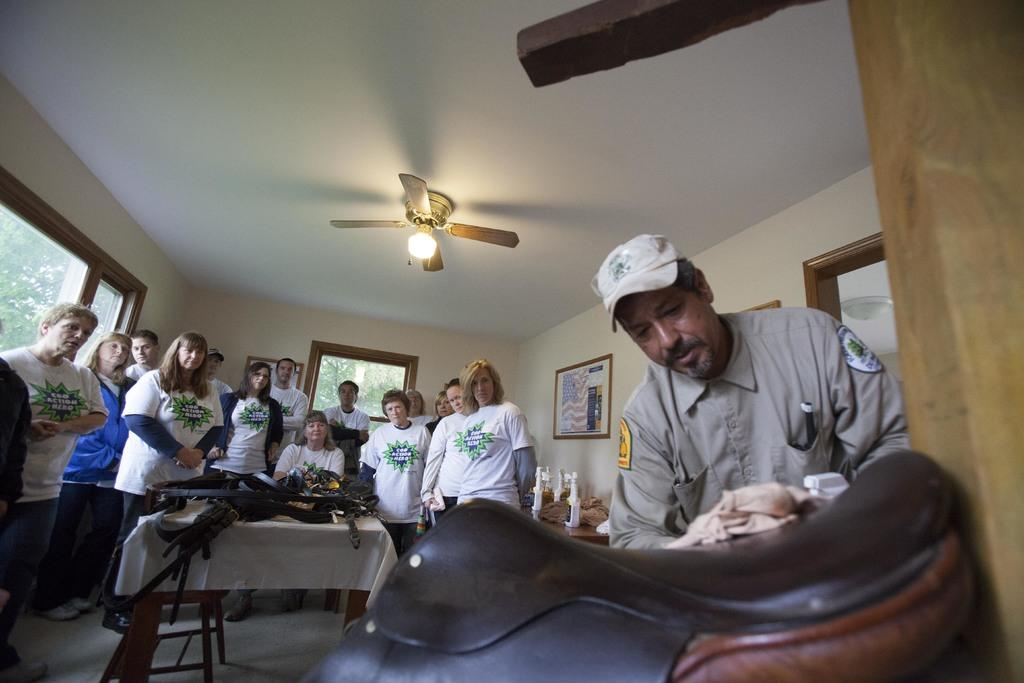How many people are in total are in the room? There is a group of people in the room, but the exact number is not specified. What is located in front of the group of people? There is a table in front of the group of people. Can you describe the fan in the image? The fan is located on top of the roof. What can be seen in the background of the room? There is a wall frame in the background. What type of wilderness can be seen through the window in the room? There is no window or wilderness mentioned in the image. How many pets are present in the room? The facts do not mention any pets in the room. What type of creature is sitting on the table in front of the group of people? There is no creature mentioned in the image. 